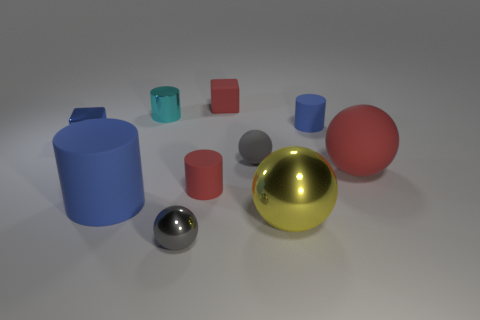How many small red cylinders have the same material as the large red sphere?
Your answer should be compact. 1. What is the color of the tiny sphere that is made of the same material as the large blue cylinder?
Give a very brief answer. Gray. Does the red matte block have the same size as the red object that is right of the big yellow thing?
Give a very brief answer. No. What is the material of the small cylinder that is behind the tiny matte cylinder that is behind the small thing to the left of the tiny cyan metal object?
Ensure brevity in your answer.  Metal. What number of things are gray cylinders or small gray balls?
Your answer should be compact. 2. There is a sphere left of the gray matte thing; does it have the same color as the matte sphere that is on the left side of the red rubber sphere?
Your response must be concise. Yes. The blue metal object that is the same size as the gray metal sphere is what shape?
Make the answer very short. Cube. How many things are either shiny objects to the left of the big blue cylinder or small objects that are in front of the red ball?
Keep it short and to the point. 3. Are there fewer small green shiny cylinders than blue cubes?
Your answer should be very brief. Yes. There is a cyan cylinder that is the same size as the gray shiny thing; what is its material?
Keep it short and to the point. Metal. 